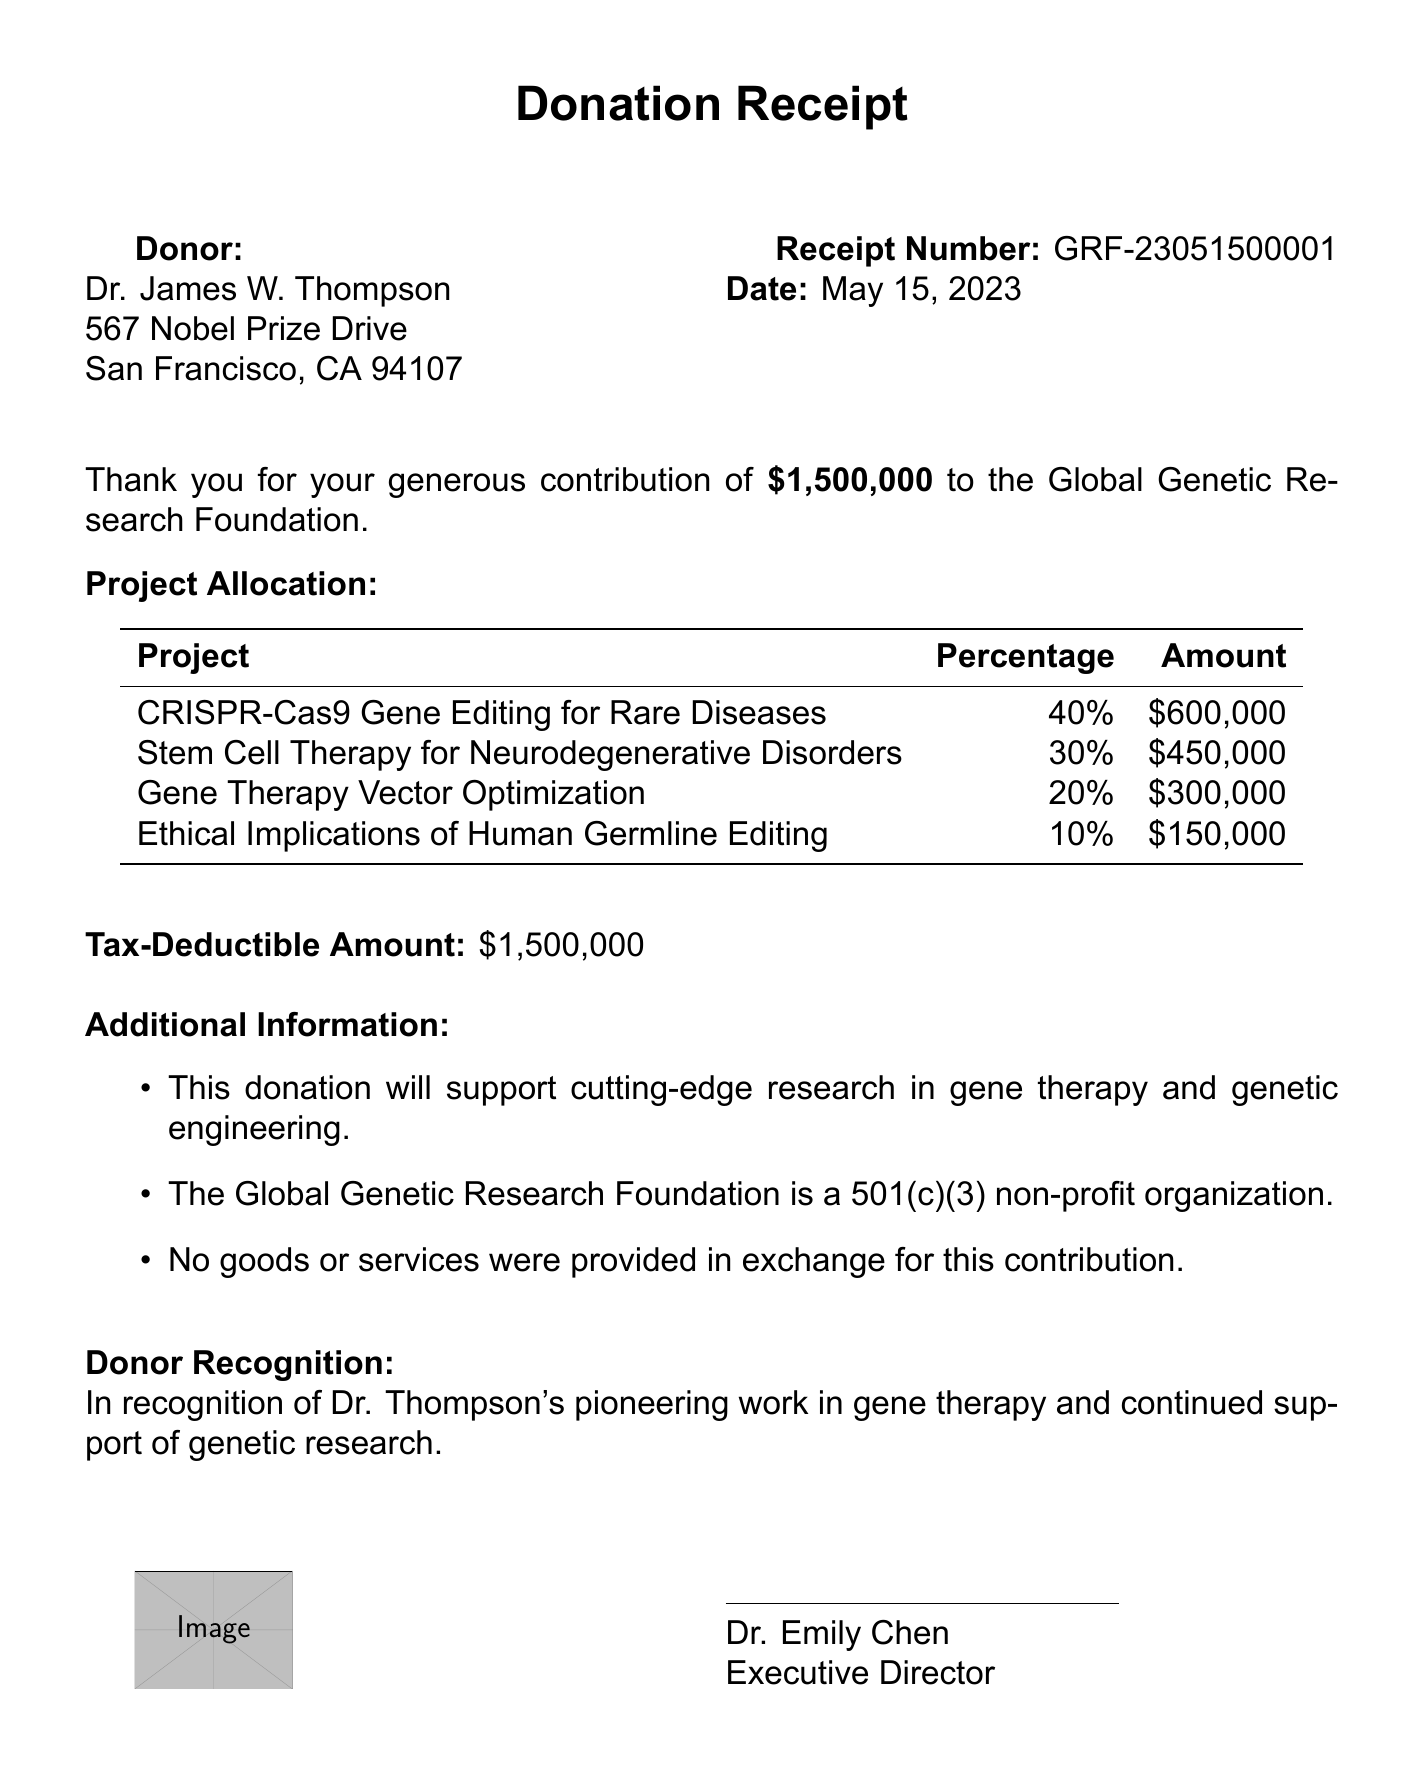What is the foundation's name? The foundation's name can be found at the top of the document.
Answer: Global Genetic Research Foundation Who is the authorized signatory? The authorized signatory is listed at the end of the document.
Answer: Dr. Emily Chen What is the donation amount? The donation amount is mentioned in a prominent section of the document.
Answer: $1,500,000 What is the tax-deductible amount? The tax-deductible amount is specified in the document after the donation amount.
Answer: $1,500,000 How much is allocated to Stem Cell Therapy for Neurodegenerative Disorders? This information can be found in the project allocation table.
Answer: $450,000 What percentage of the donation is allocated to Gene Therapy Vector Optimization? The allocation percentage for this project is listed in the project allocation table.
Answer: 20% What is the receipt number? The receipt number is provided in the top right section of the document.
Answer: GRF-23051500001 What is the date of the donation? The date of the donation is mentioned alongside the receipt number.
Answer: May 15, 2023 Is the Global Genetic Research Foundation a non-profit organization? This information is included in the additional information section.
Answer: Yes 